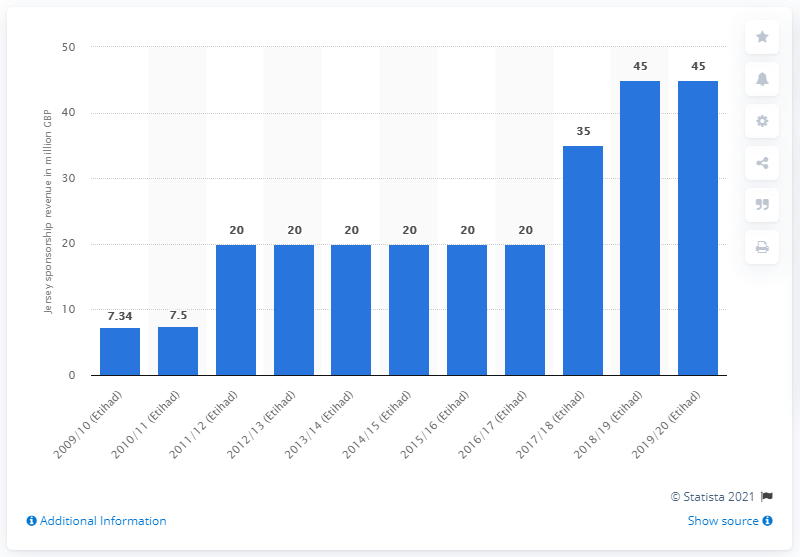List a handful of essential elements in this visual. Manchester City received £45 million from Etihad in the 2019/20 season. 